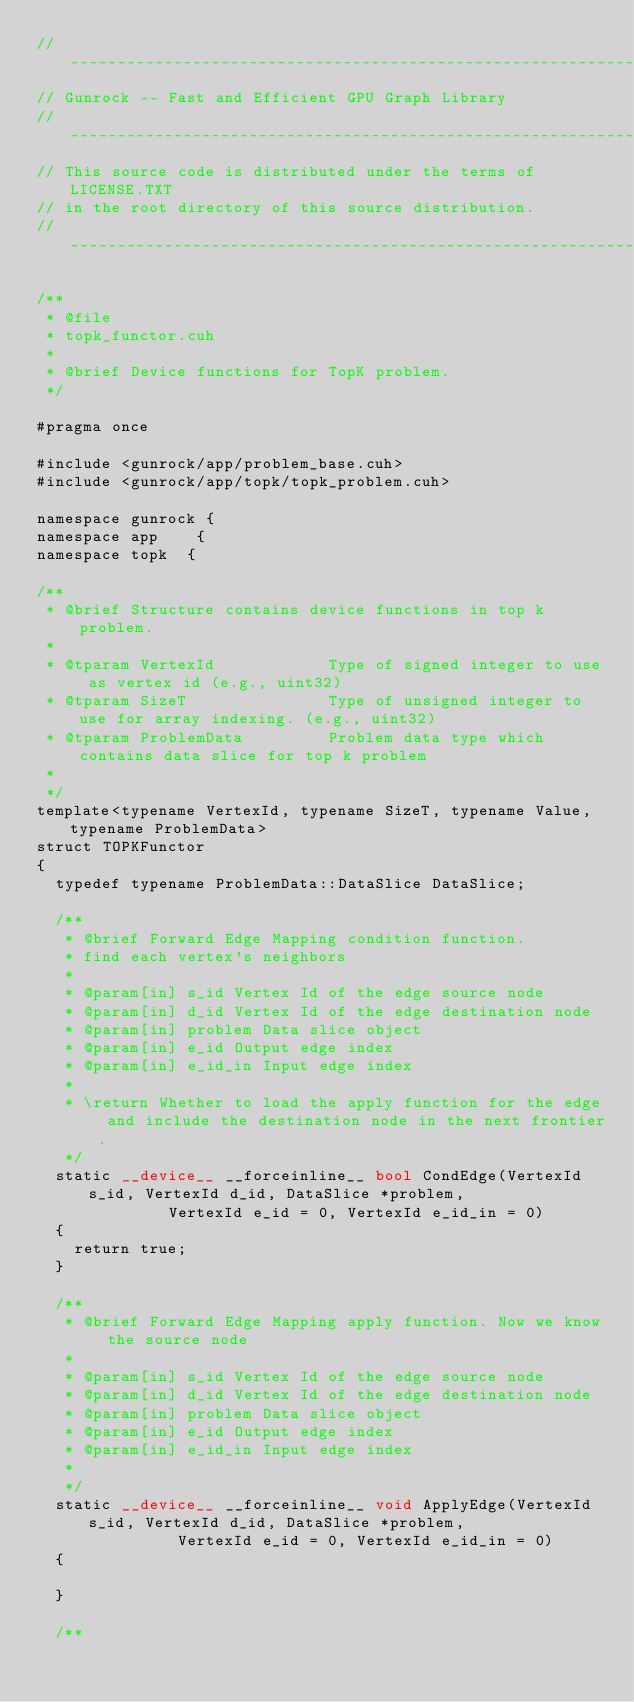Convert code to text. <code><loc_0><loc_0><loc_500><loc_500><_Cuda_>// ----------------------------------------------------------------
// Gunrock -- Fast and Efficient GPU Graph Library
// ----------------------------------------------------------------
// This source code is distributed under the terms of LICENSE.TXT
// in the root directory of this source distribution.
// ----------------------------------------------------------------

/**
 * @file
 * topk_functor.cuh
 *
 * @brief Device functions for TopK problem.
 */

#pragma once

#include <gunrock/app/problem_base.cuh>
#include <gunrock/app/topk/topk_problem.cuh>

namespace gunrock {
namespace app    {
namespace topk  {

/**
 * @brief Structure contains device functions in top k problem.
 *
 * @tparam VertexId            Type of signed integer to use as vertex id (e.g., uint32)
 * @tparam SizeT               Type of unsigned integer to use for array indexing. (e.g., uint32)
 * @tparam ProblemData         Problem data type which contains data slice for top k problem
 *
 */
template<typename VertexId, typename SizeT, typename Value, typename ProblemData>
struct TOPKFunctor
{
  typedef typename ProblemData::DataSlice DataSlice;
  
  /**
   * @brief Forward Edge Mapping condition function.
   * find each vertex's neighbors
   *
   * @param[in] s_id Vertex Id of the edge source node
   * @param[in] d_id Vertex Id of the edge destination node
   * @param[in] problem Data slice object
   * @param[in] e_id Output edge index
   * @param[in] e_id_in Input edge index
   *
   * \return Whether to load the apply function for the edge and include the destination node in the next frontier.
   */
  static __device__ __forceinline__ bool CondEdge(VertexId s_id, VertexId d_id, DataSlice *problem, 
						  VertexId e_id = 0, VertexId e_id_in = 0)
  {
    return true;
  }
  
  /**
   * @brief Forward Edge Mapping apply function. Now we know the source node
   *
   * @param[in] s_id Vertex Id of the edge source node
   * @param[in] d_id Vertex Id of the edge destination node
   * @param[in] problem Data slice object
   * @param[in] e_id Output edge index
   * @param[in] e_id_in Input edge index
   *
   */
  static __device__ __forceinline__ void ApplyEdge(VertexId s_id, VertexId d_id, DataSlice *problem, 
						   VertexId e_id = 0, VertexId e_id_in = 0)
  {
  
  }
  
  /**</code> 